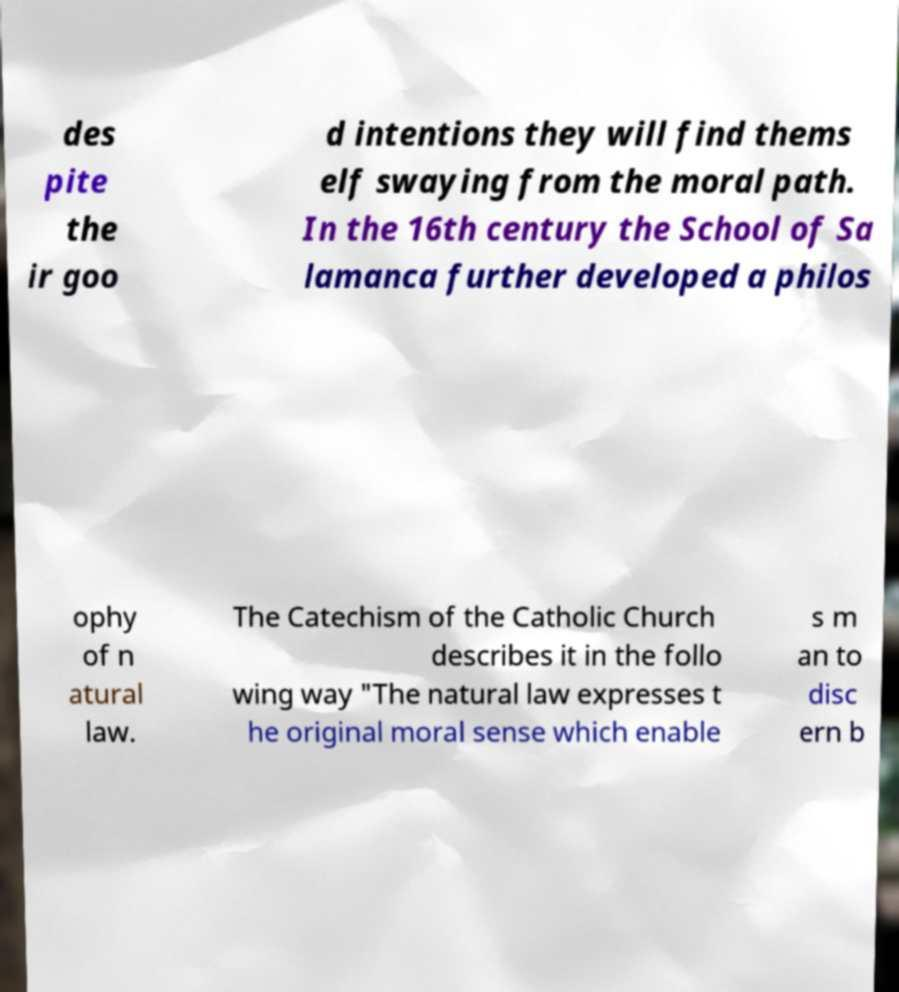Can you accurately transcribe the text from the provided image for me? des pite the ir goo d intentions they will find thems elf swaying from the moral path. In the 16th century the School of Sa lamanca further developed a philos ophy of n atural law. The Catechism of the Catholic Church describes it in the follo wing way "The natural law expresses t he original moral sense which enable s m an to disc ern b 